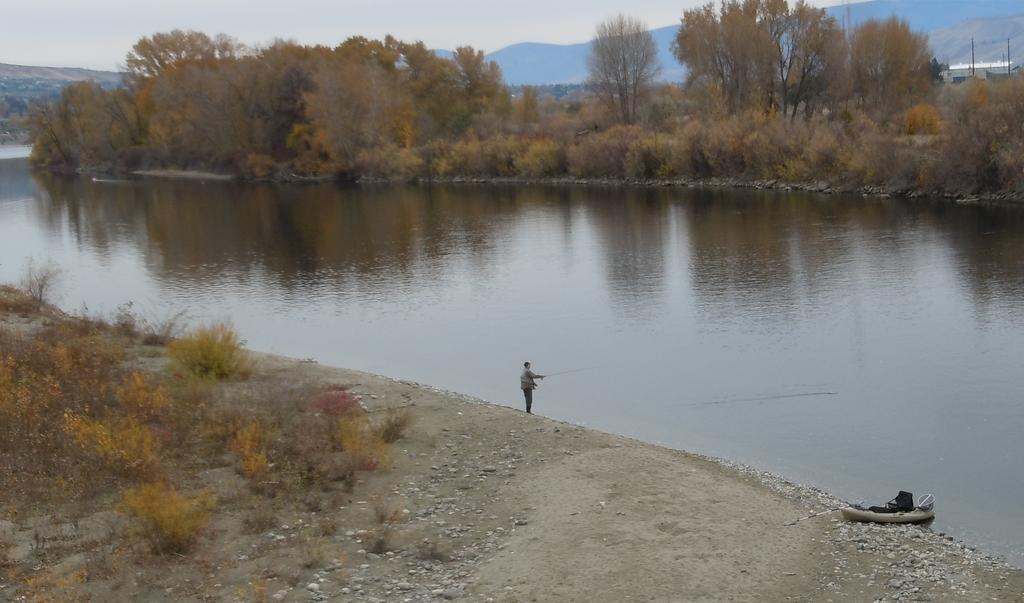Please provide a concise description of this image. In this image I can see a person standing wearing gray color jacket and black color pant. I can also see a boat which is in white color, background I can see trees in green color and the sky is in blue and white color. 